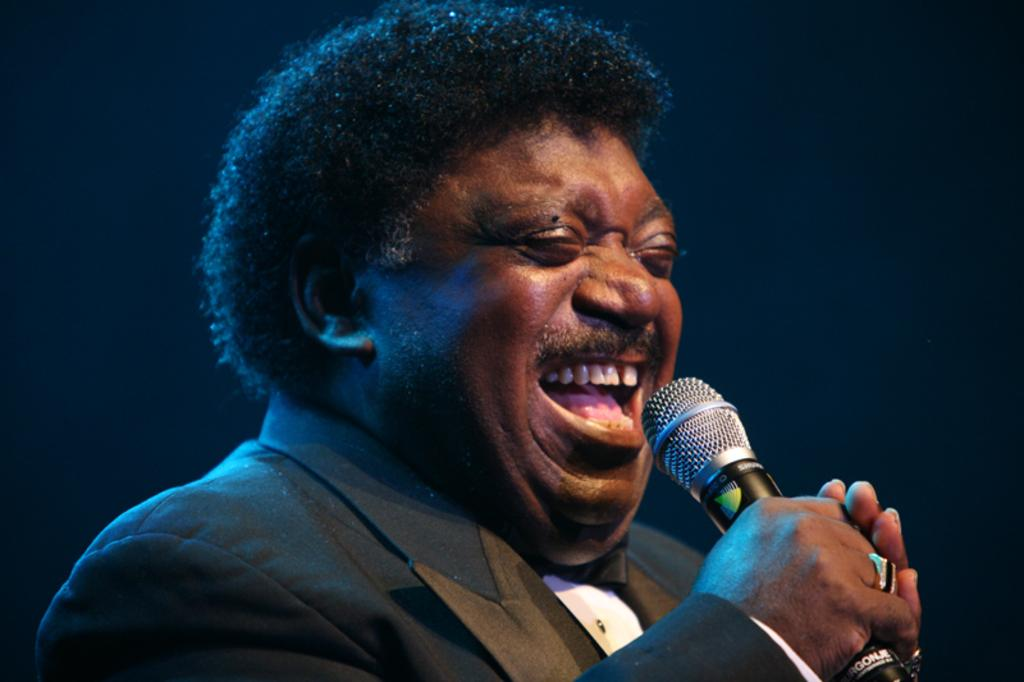What is the main subject of the image? There is a man in the image. What is the man doing in the image? The man is singing in the image. What object is the man interacting with in the image? The man is in front of a microphone in the image. What type of knee injury is the man experiencing in the image? There is no indication of a knee injury in the image; the man is singing and standing in front of a microphone. 